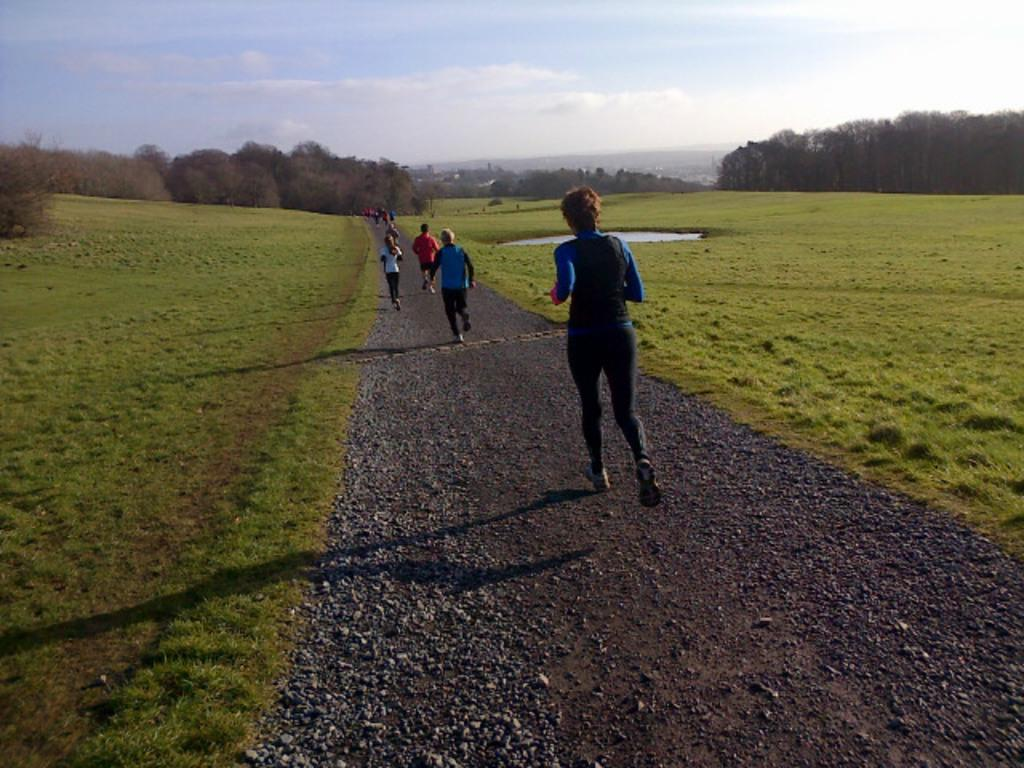What are the people in the image doing? The people in the image are running on the road. What can be seen in the background of the image? There are trees, water, and ground visible in the background of the image. What is visible in the sky at the top of the image? There are clouds in the sky at the top of the image. How many balloons are being carried by the people running in the image? There are no balloons visible in the image; the people are running without any balloons. What type of cushion is being used by the people running in the image? There is no cushion present in the image; the people are running on the road without any cushions. 